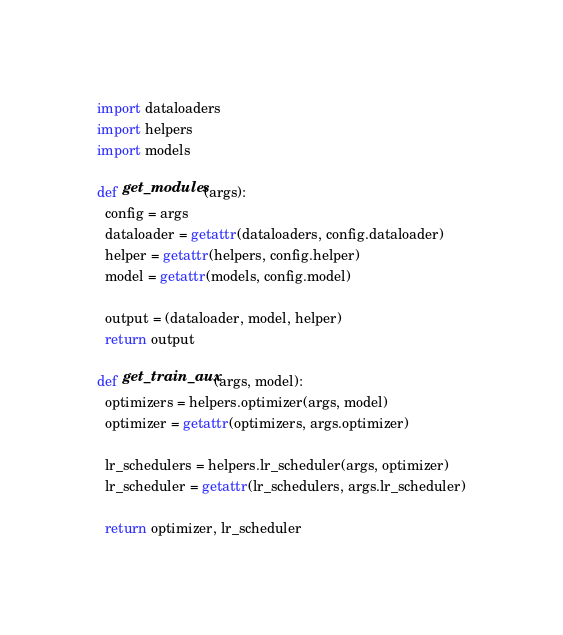<code> <loc_0><loc_0><loc_500><loc_500><_Python_>import dataloaders
import helpers
import models

def get_modules(args):
  config = args
  dataloader = getattr(dataloaders, config.dataloader)
  helper = getattr(helpers, config.helper)
  model = getattr(models, config.model)

  output = (dataloader, model, helper)
  return output

def get_train_aux(args, model):
  optimizers = helpers.optimizer(args, model)
  optimizer = getattr(optimizers, args.optimizer)

  lr_schedulers = helpers.lr_scheduler(args, optimizer)
  lr_scheduler = getattr(lr_schedulers, args.lr_scheduler)

  return optimizer, lr_scheduler</code> 